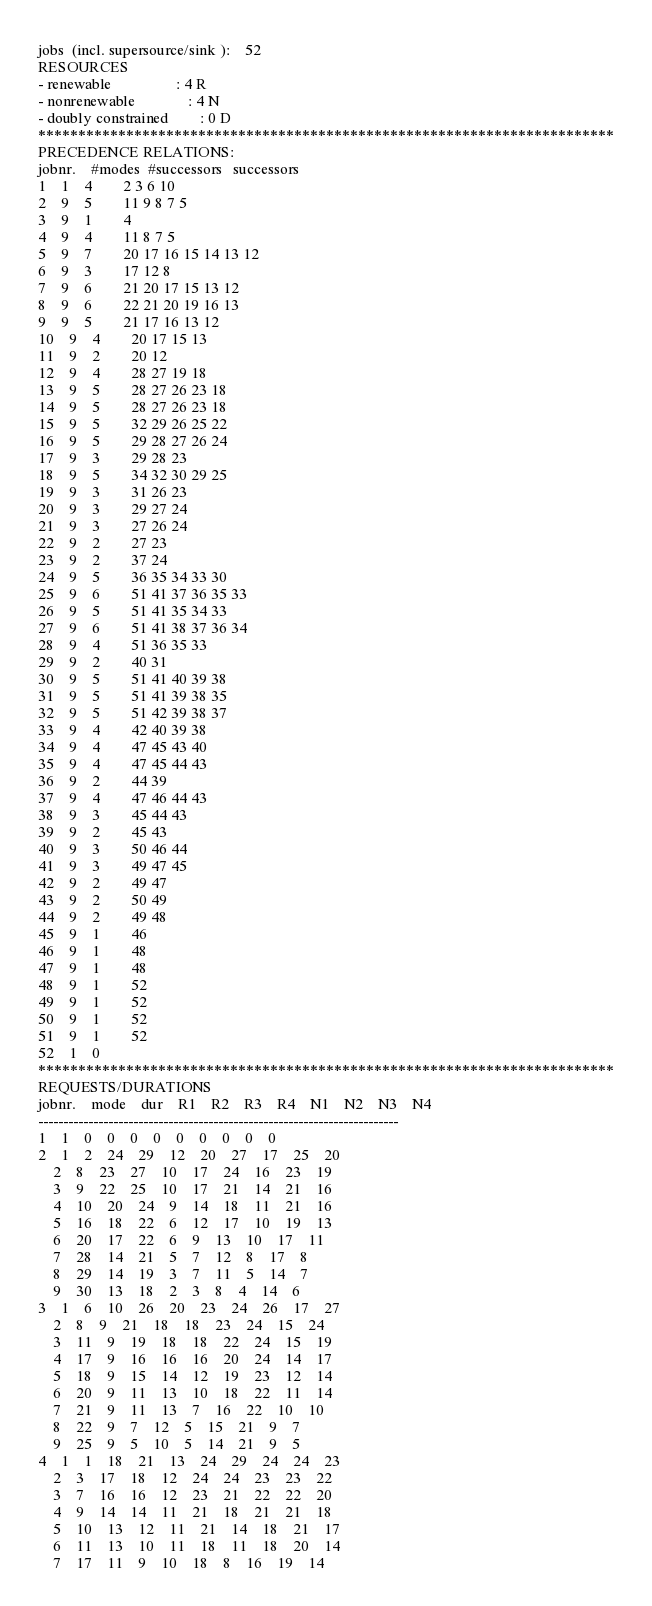Convert code to text. <code><loc_0><loc_0><loc_500><loc_500><_ObjectiveC_>jobs  (incl. supersource/sink ):	52
RESOURCES
- renewable                 : 4 R
- nonrenewable              : 4 N
- doubly constrained        : 0 D
************************************************************************
PRECEDENCE RELATIONS:
jobnr.    #modes  #successors   successors
1	1	4		2 3 6 10 
2	9	5		11 9 8 7 5 
3	9	1		4 
4	9	4		11 8 7 5 
5	9	7		20 17 16 15 14 13 12 
6	9	3		17 12 8 
7	9	6		21 20 17 15 13 12 
8	9	6		22 21 20 19 16 13 
9	9	5		21 17 16 13 12 
10	9	4		20 17 15 13 
11	9	2		20 12 
12	9	4		28 27 19 18 
13	9	5		28 27 26 23 18 
14	9	5		28 27 26 23 18 
15	9	5		32 29 26 25 22 
16	9	5		29 28 27 26 24 
17	9	3		29 28 23 
18	9	5		34 32 30 29 25 
19	9	3		31 26 23 
20	9	3		29 27 24 
21	9	3		27 26 24 
22	9	2		27 23 
23	9	2		37 24 
24	9	5		36 35 34 33 30 
25	9	6		51 41 37 36 35 33 
26	9	5		51 41 35 34 33 
27	9	6		51 41 38 37 36 34 
28	9	4		51 36 35 33 
29	9	2		40 31 
30	9	5		51 41 40 39 38 
31	9	5		51 41 39 38 35 
32	9	5		51 42 39 38 37 
33	9	4		42 40 39 38 
34	9	4		47 45 43 40 
35	9	4		47 45 44 43 
36	9	2		44 39 
37	9	4		47 46 44 43 
38	9	3		45 44 43 
39	9	2		45 43 
40	9	3		50 46 44 
41	9	3		49 47 45 
42	9	2		49 47 
43	9	2		50 49 
44	9	2		49 48 
45	9	1		46 
46	9	1		48 
47	9	1		48 
48	9	1		52 
49	9	1		52 
50	9	1		52 
51	9	1		52 
52	1	0		
************************************************************************
REQUESTS/DURATIONS
jobnr.	mode	dur	R1	R2	R3	R4	N1	N2	N3	N4	
------------------------------------------------------------------------
1	1	0	0	0	0	0	0	0	0	0	
2	1	2	24	29	12	20	27	17	25	20	
	2	8	23	27	10	17	24	16	23	19	
	3	9	22	25	10	17	21	14	21	16	
	4	10	20	24	9	14	18	11	21	16	
	5	16	18	22	6	12	17	10	19	13	
	6	20	17	22	6	9	13	10	17	11	
	7	28	14	21	5	7	12	8	17	8	
	8	29	14	19	3	7	11	5	14	7	
	9	30	13	18	2	3	8	4	14	6	
3	1	6	10	26	20	23	24	26	17	27	
	2	8	9	21	18	18	23	24	15	24	
	3	11	9	19	18	18	22	24	15	19	
	4	17	9	16	16	16	20	24	14	17	
	5	18	9	15	14	12	19	23	12	14	
	6	20	9	11	13	10	18	22	11	14	
	7	21	9	11	13	7	16	22	10	10	
	8	22	9	7	12	5	15	21	9	7	
	9	25	9	5	10	5	14	21	9	5	
4	1	1	18	21	13	24	29	24	24	23	
	2	3	17	18	12	24	24	23	23	22	
	3	7	16	16	12	23	21	22	22	20	
	4	9	14	14	11	21	18	21	21	18	
	5	10	13	12	11	21	14	18	21	17	
	6	11	13	10	11	18	11	18	20	14	
	7	17	11	9	10	18	8	16	19	14	</code> 